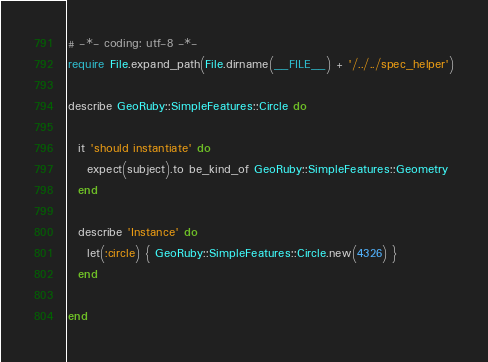<code> <loc_0><loc_0><loc_500><loc_500><_Ruby_># -*- coding: utf-8 -*-
require File.expand_path(File.dirname(__FILE__) + '/../../spec_helper')

describe GeoRuby::SimpleFeatures::Circle do

  it 'should instantiate' do
    expect(subject).to be_kind_of GeoRuby::SimpleFeatures::Geometry
  end

  describe 'Instance' do
    let(:circle) { GeoRuby::SimpleFeatures::Circle.new(4326) }
  end

end
</code> 